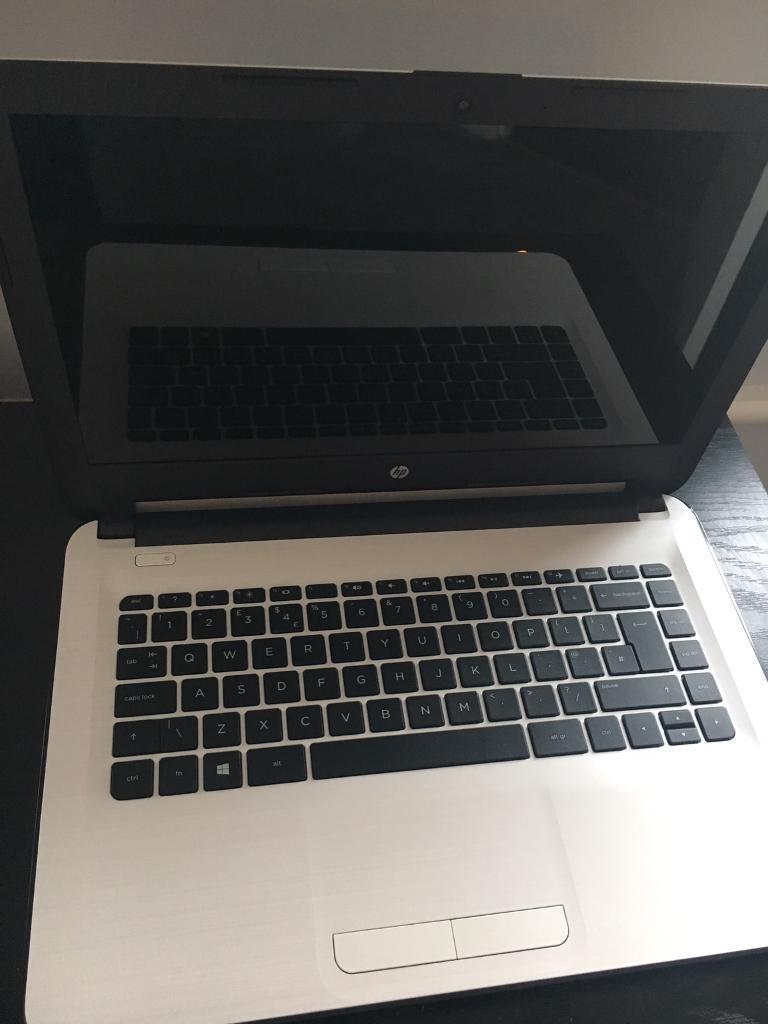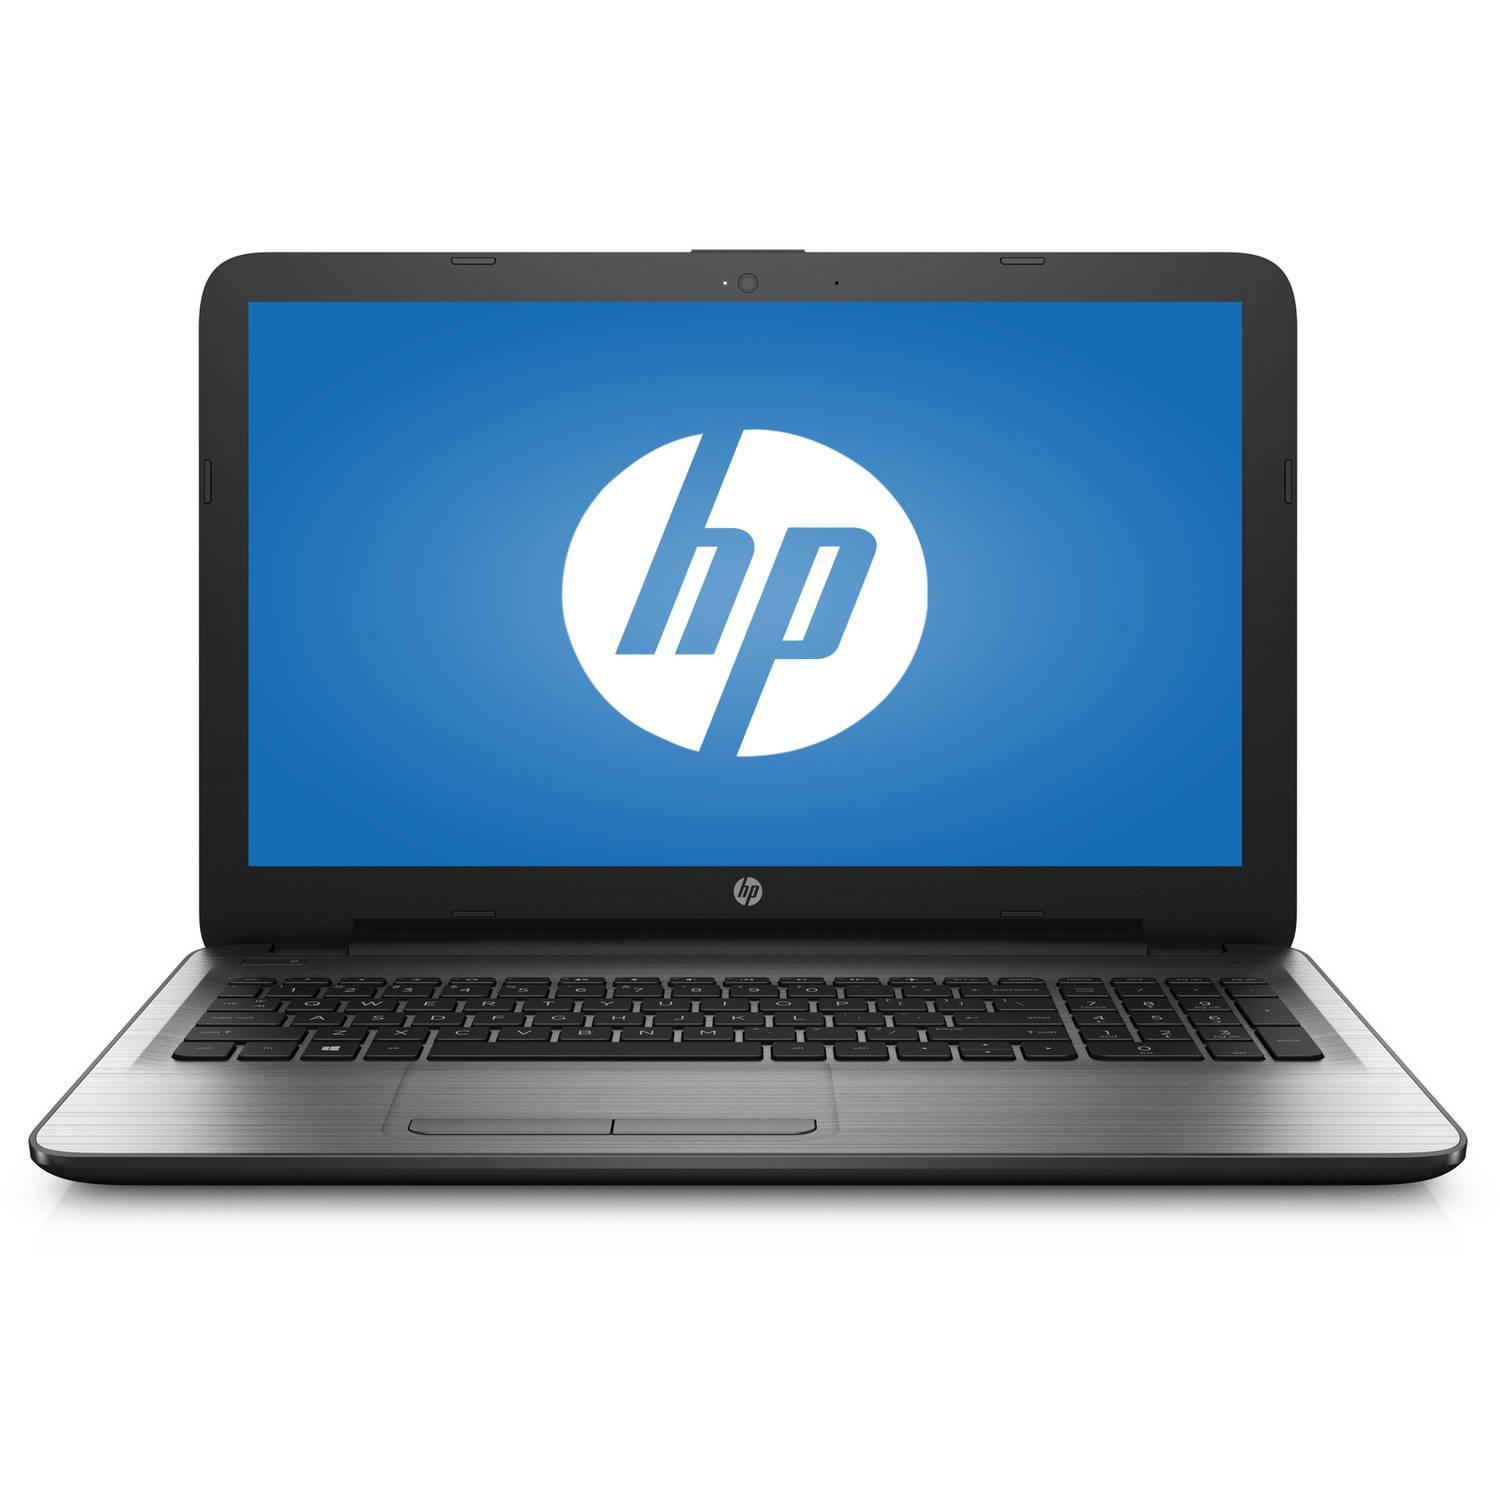The first image is the image on the left, the second image is the image on the right. Evaluate the accuracy of this statement regarding the images: "There is an open laptop with a white screen displayed that features a blue circular logo". Is it true? Answer yes or no. No. The first image is the image on the left, the second image is the image on the right. For the images displayed, is the sentence "A laptop is turned so the screen is visible, and another laptop is turned so the back of the screen is visible." factually correct? Answer yes or no. No. 